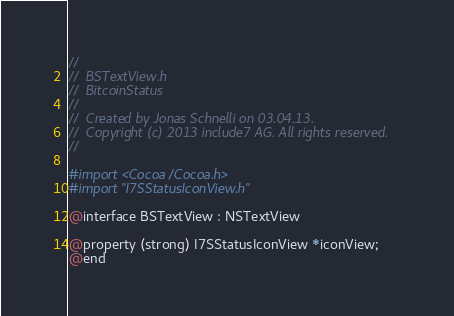Convert code to text. <code><loc_0><loc_0><loc_500><loc_500><_C_>//
//  BSTextView.h
//  BitcoinStatus
//
//  Created by Jonas Schnelli on 03.04.13.
//  Copyright (c) 2013 include7 AG. All rights reserved.
//

#import <Cocoa/Cocoa.h>
#import "I7SStatusIconView.h"

@interface BSTextView : NSTextView 

@property (strong) I7SStatusIconView *iconView;
@end
</code> 